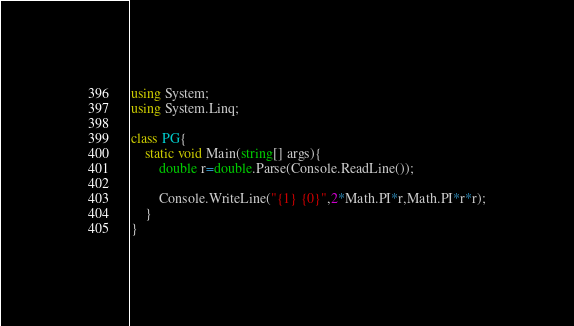Convert code to text. <code><loc_0><loc_0><loc_500><loc_500><_C#_>using System;
using System.Linq;

class PG{
    static void Main(string[] args){
        double r=double.Parse(Console.ReadLine());

        Console.WriteLine("{1} {0}",2*Math.PI*r,Math.PI*r*r);
    }
}
</code> 